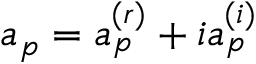Convert formula to latex. <formula><loc_0><loc_0><loc_500><loc_500>a _ { p } = a _ { p } ^ { ( r ) } + i a _ { p } ^ { ( i ) }</formula> 